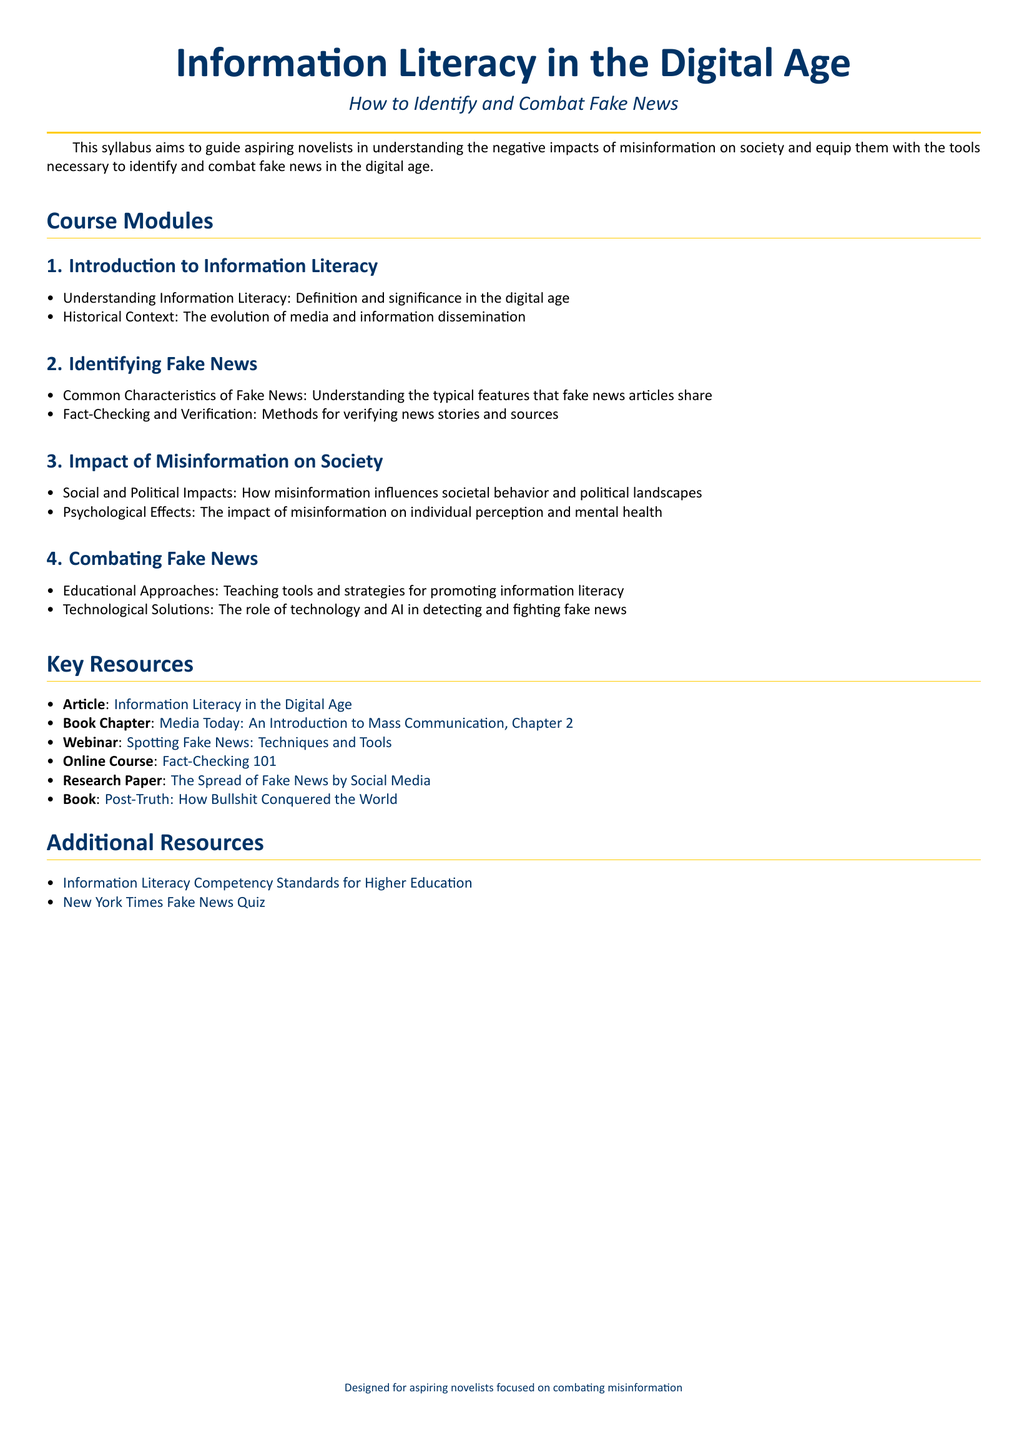What is the title of the syllabus? The title is presented prominently at the beginning of the document, identifying the focus of the syllabus.
Answer: Information Literacy in the Digital Age What is the main goal of the syllabus? The goal is stated in the introductory section, highlighting the purpose of the syllabus for aspiring novelists.
Answer: Guide aspiring novelists in understanding the negative impacts of misinformation on society How many modules are outlined in the syllabus? The total number of distinct course modules is specified in the document.
Answer: 4 What is the first topic in the "Combating Fake News" module? The first topic is listed in the sequence of items under the "Combating Fake News" module.
Answer: Educational Approaches Which online course is mentioned as a resource? The resource list includes specific titles for further learning; the online course is one of them.
Answer: Fact-Checking 101 What color is the title section? The document specifies colors used for different sections to enhance visibility.
Answer: Main color 